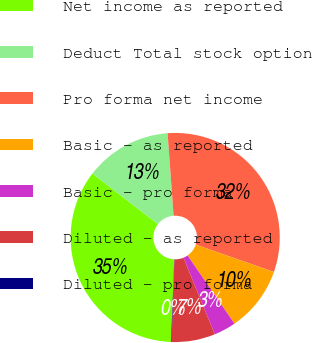Convert chart. <chart><loc_0><loc_0><loc_500><loc_500><pie_chart><fcel>Net income as reported<fcel>Deduct Total stock option<fcel>Pro forma net income<fcel>Basic - as reported<fcel>Basic - pro forma<fcel>Diluted - as reported<fcel>Diluted - pro forma<nl><fcel>34.82%<fcel>13.38%<fcel>31.5%<fcel>10.06%<fcel>3.41%<fcel>6.74%<fcel>0.09%<nl></chart> 